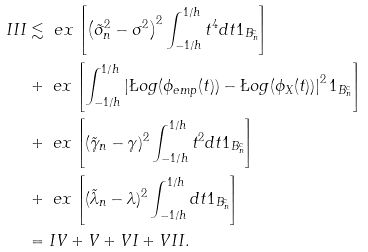Convert formula to latex. <formula><loc_0><loc_0><loc_500><loc_500>I I I & \lesssim \ e x \left [ \left ( { \tilde { \sigma } _ { n } ^ { 2 } } - { \sigma ^ { 2 } } \right ) ^ { 2 } \int _ { - 1 / h } ^ { 1 / h } t ^ { 4 } d t 1 _ { B _ { n } ^ { c } } \right ] \\ & + \ e x \left [ \int _ { - 1 / h } ^ { 1 / h } \left | \L o g ( \phi _ { e m p } ( t ) ) - \L o g ( \phi _ { X } ( t ) ) \right | ^ { 2 } 1 _ { B _ { n } ^ { c } } \right ] \\ & + \ e x \left [ ( \tilde { \gamma } _ { n } - \gamma ) ^ { 2 } \int _ { - 1 / h } ^ { 1 / h } t ^ { 2 } d t 1 _ { B _ { n } ^ { c } } \right ] \\ & + \ e x \left [ ( \tilde { \lambda } _ { n } - \lambda ) ^ { 2 } \int _ { - 1 / h } ^ { 1 / h } d t 1 _ { B _ { n } ^ { c } } \right ] \\ & = I V + V + V I + V I I .</formula> 